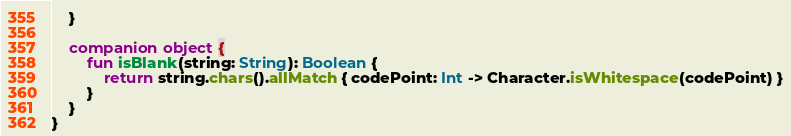<code> <loc_0><loc_0><loc_500><loc_500><_Kotlin_>    }

    companion object {
        fun isBlank(string: String): Boolean {
            return string.chars().allMatch { codePoint: Int -> Character.isWhitespace(codePoint) }
        }
    }
}
</code> 